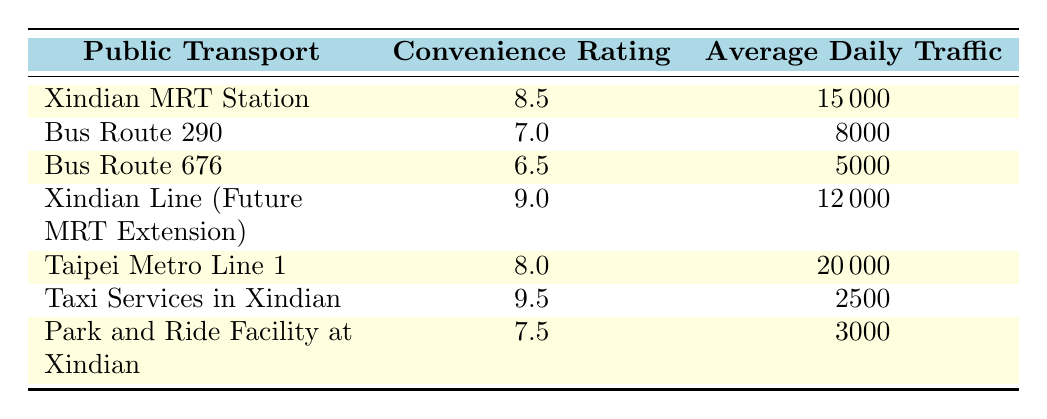What's the highest convenience rating among the public transport options? Looking through the table, the maximum convenience rating found is 9.5, which belongs to the "Taxi Services in Xindian."
Answer: 9.5 What is the average daily traffic for the Bus Route 290? The table lists the average daily traffic for Bus Route 290 as 8000.
Answer: 8000 Is the convenience rating for Xindian MRT Station higher than that of Bus Route 676? The convenience rating for Xindian MRT Station is 8.5, while for Bus Route 676 it is 6.5. Since 8.5 is greater than 6.5, the statement is true.
Answer: Yes What is the total average daily traffic for all the public transport options? To find the total average daily traffic, sum the values: 15000 + 8000 + 5000 + 12000 + 20000 + 2500 + 3000 = 60000.
Answer: 60000 How many public transport options have a convenience rating of 8 or above? The options with a rating of 8 or above are Xindian MRT Station (8.5), Xindian Line (Future MRT Extension) (9.0), Taipei Metro Line 1 (8.0), and Taxi Services in Xindian (9.5), totaling 4 options.
Answer: 4 Which public transport option has the lowest average daily traffic? The table indicates that "Taxi Services in Xindian" has the lowest average daily traffic at 2500.
Answer: Taxi Services in Xindian What is the difference in convenience ratings between the Bus Route 290 and the Xindian Line (Future MRT Extension)? The convenience rating for Bus Route 290 is 7.0, and for the Xindian Line (Future MRT Extension) it is 9.0. The difference is calculated as 9.0 - 7.0 = 2.0.
Answer: 2.0 Are there any public transport options with an average daily traffic of over 15000? Reviewing the table, only Taipei Metro Line 1 has an average daily traffic that exceeds 15000, which is at 20000.
Answer: Yes What is the average convenience rating of the public transport options listed? The average convenience rating is calculated by adding the ratings: (8.5 + 7.0 + 6.5 + 9.0 + 8.0 + 9.5 + 7.5) / 7 = 8.0.
Answer: 8.0 